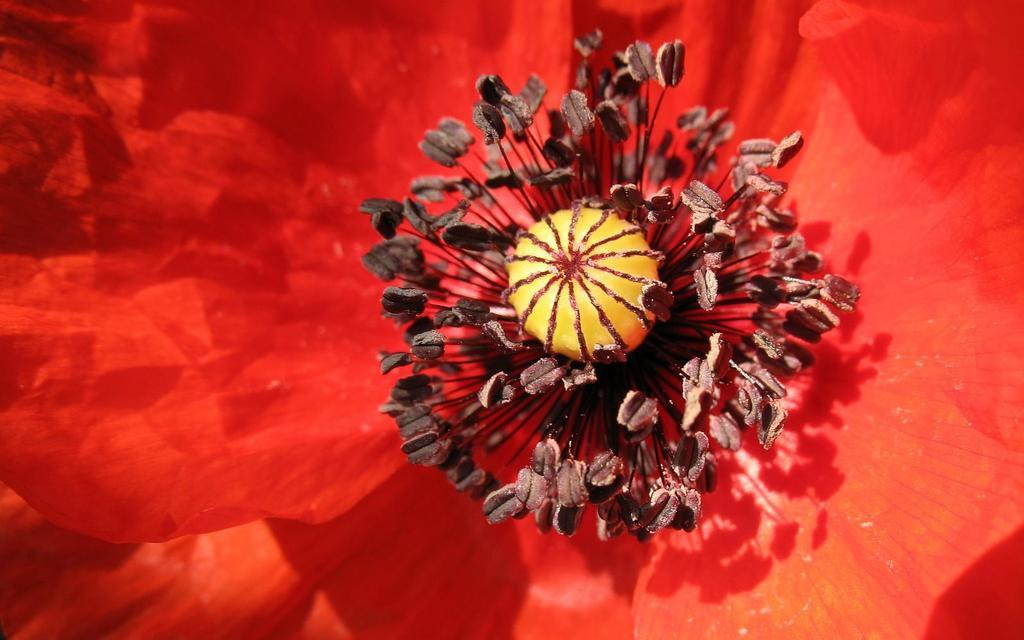What type of flower is present in the image? There is a red flower in the image. What part of the flower can be seen in the image? The red flower has a stigma. What is present around the stigma? There are pollen grains around the stigma. What can be observed about the flower's structure at the bottom? The flower has petals at the bottom. What type of book is the yak holding in the image? There is no yak or book present in the image; it features a red flower with specific parts and structure. 